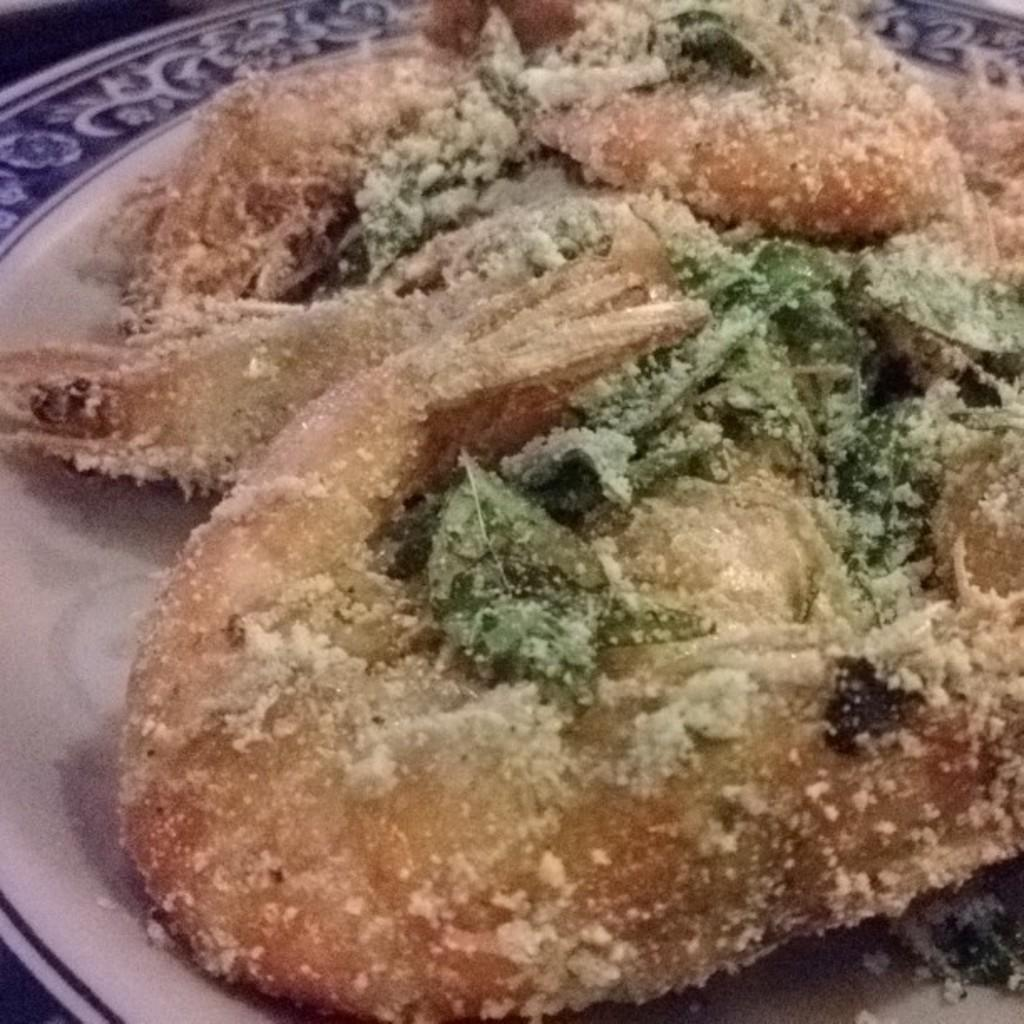What can be seen on the plate in the image? There is food present on the plate in the image. Can you describe the type of food on the plate? Unfortunately, the specific type of food cannot be determined from the provided facts. What invention is being used to generate coal in the image? There is no mention of coal or any invention in the image. 